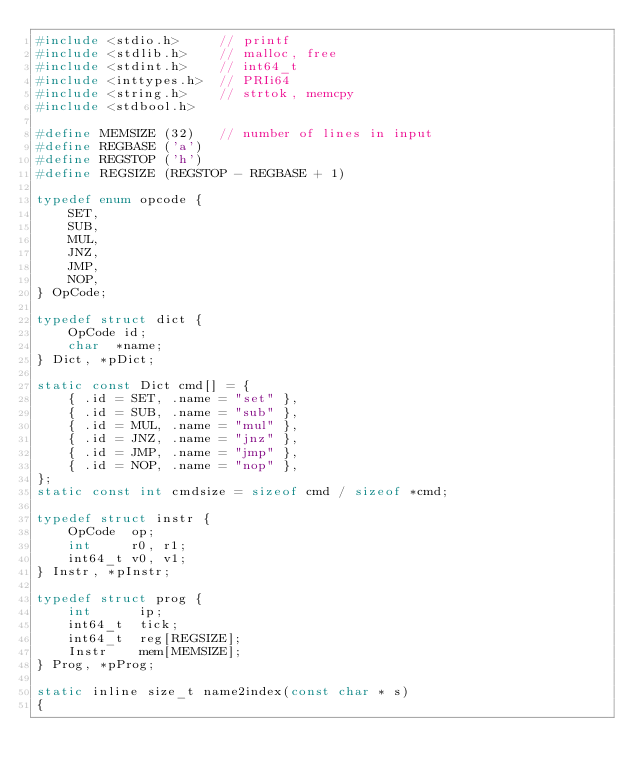<code> <loc_0><loc_0><loc_500><loc_500><_C_>#include <stdio.h>     // printf
#include <stdlib.h>    // malloc, free
#include <stdint.h>    // int64_t
#include <inttypes.h>  // PRIi64
#include <string.h>    // strtok, memcpy
#include <stdbool.h>

#define MEMSIZE (32)   // number of lines in input
#define REGBASE ('a')
#define REGSTOP ('h')
#define REGSIZE (REGSTOP - REGBASE + 1)

typedef enum opcode {
    SET,
    SUB,
    MUL,
    JNZ,
    JMP,
    NOP,
} OpCode;

typedef struct dict {
    OpCode id;
    char  *name;
} Dict, *pDict;

static const Dict cmd[] = {
    { .id = SET, .name = "set" },
    { .id = SUB, .name = "sub" },
    { .id = MUL, .name = "mul" },
    { .id = JNZ, .name = "jnz" },
    { .id = JMP, .name = "jmp" },
    { .id = NOP, .name = "nop" },
};
static const int cmdsize = sizeof cmd / sizeof *cmd;

typedef struct instr {
    OpCode  op;
    int     r0, r1;
    int64_t v0, v1;
} Instr, *pInstr;

typedef struct prog {
    int      ip;
    int64_t  tick;
    int64_t  reg[REGSIZE];
    Instr    mem[MEMSIZE];
} Prog, *pProg;

static inline size_t name2index(const char * s)
{</code> 